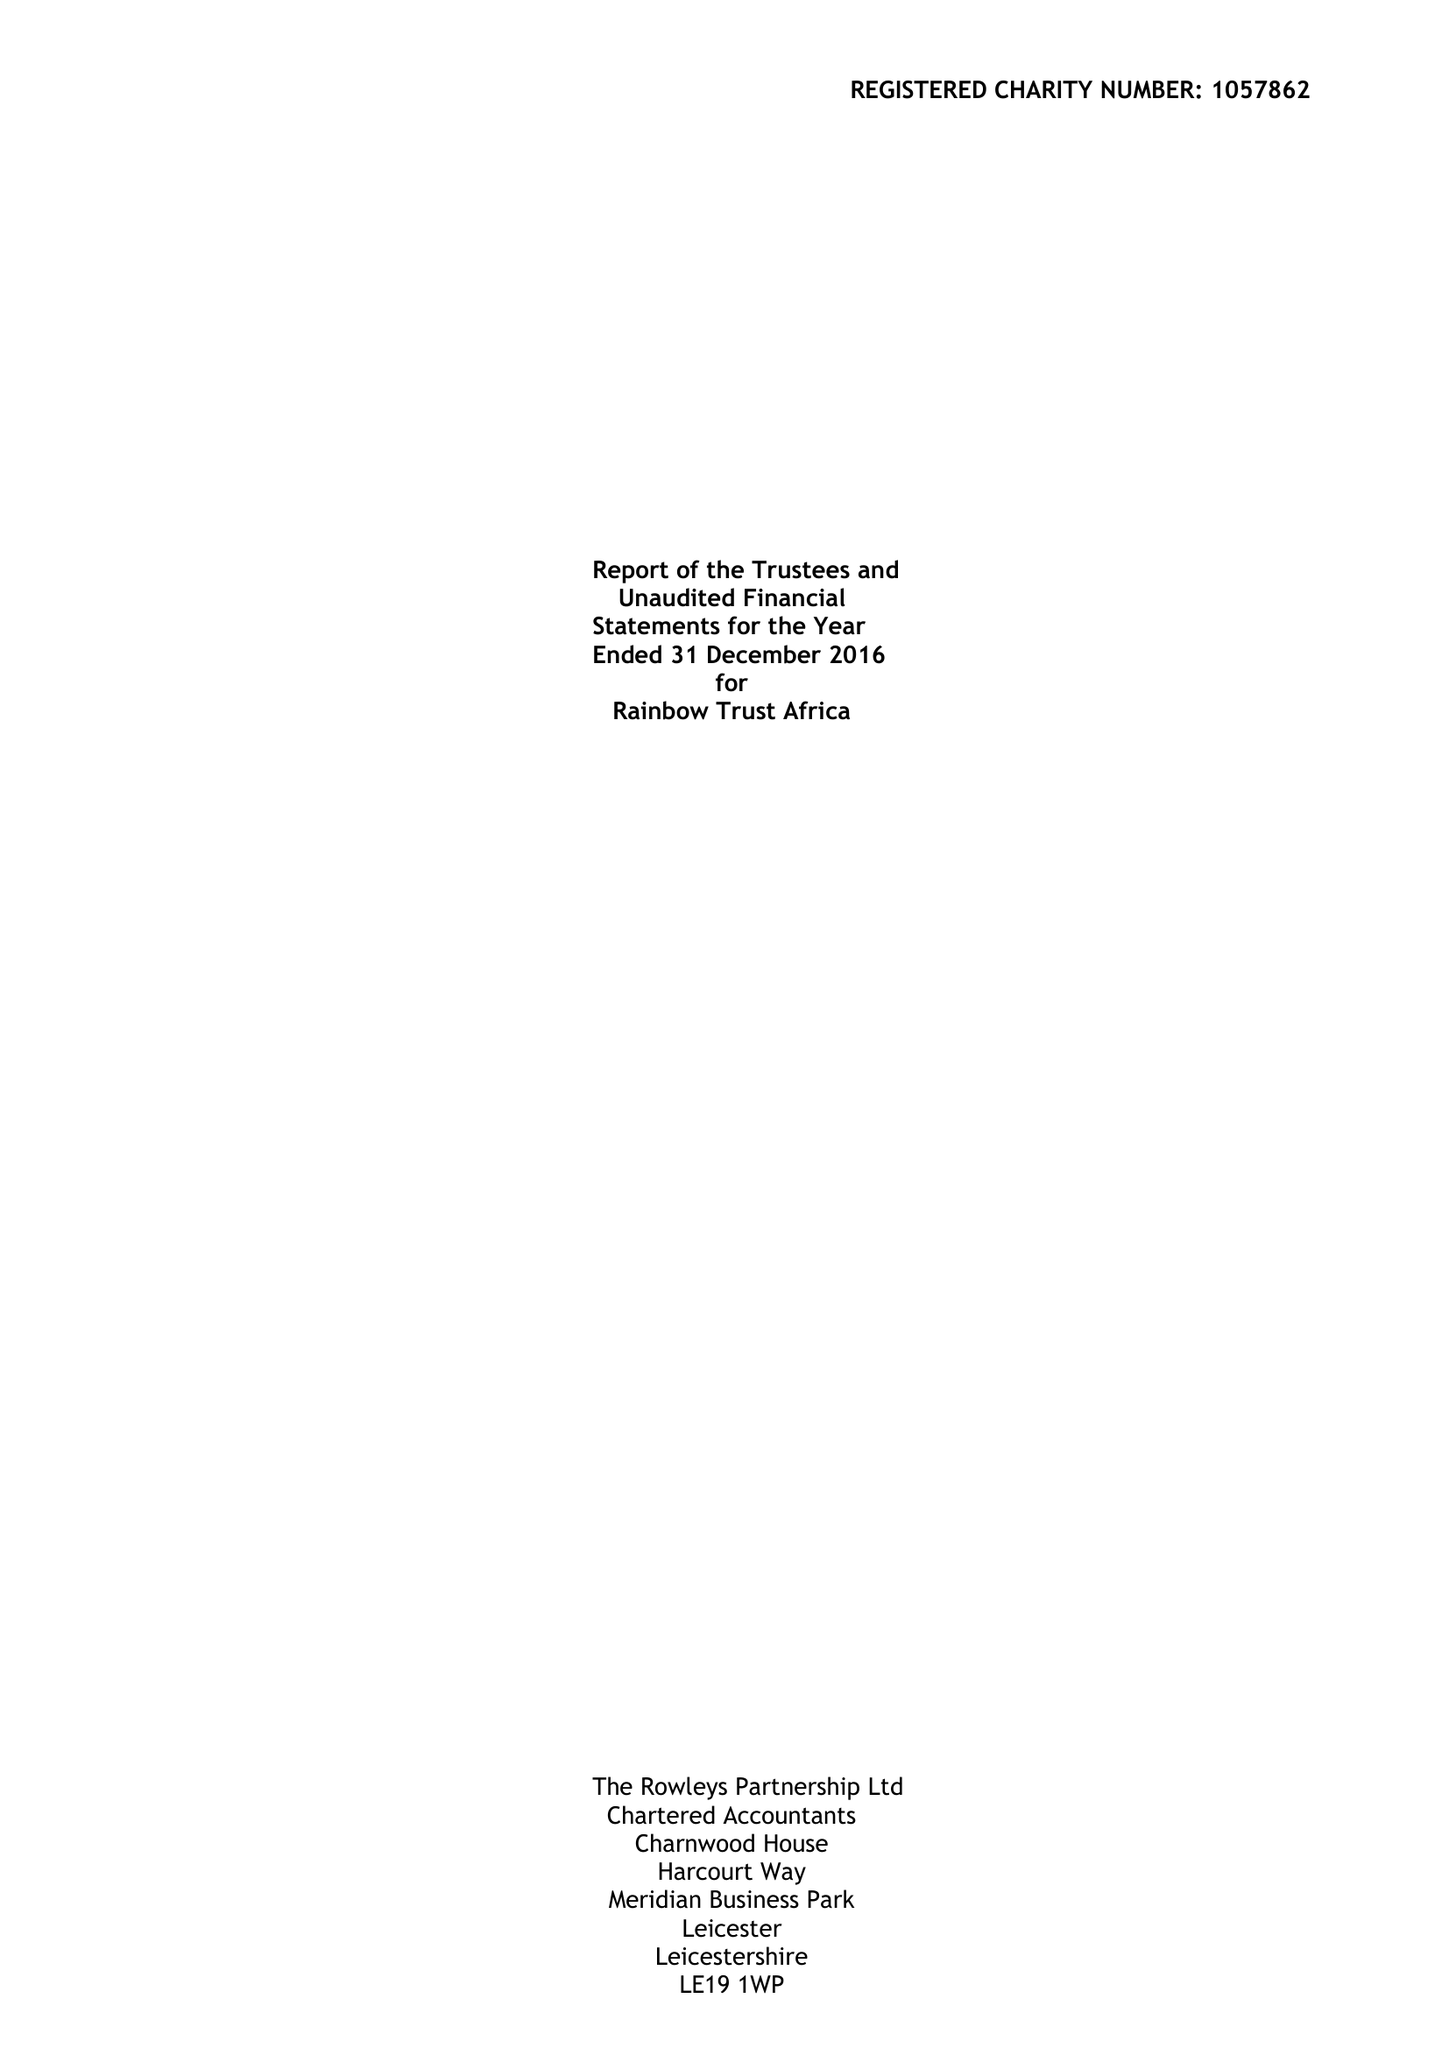What is the value for the address__postcode?
Answer the question using a single word or phrase. LE1 7GB 